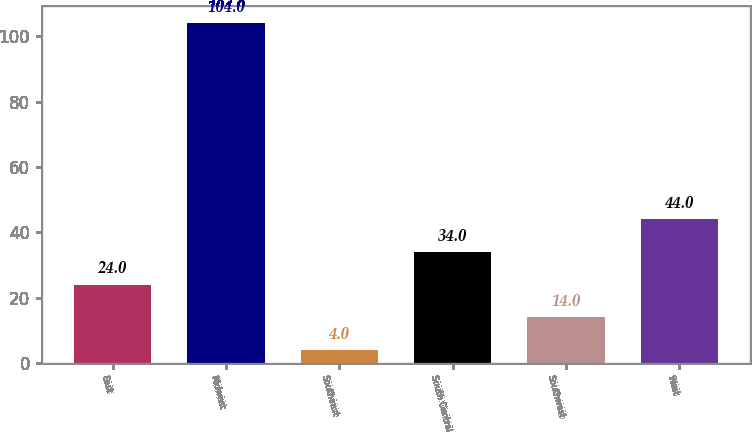Convert chart. <chart><loc_0><loc_0><loc_500><loc_500><bar_chart><fcel>East<fcel>Midwest<fcel>Southeast<fcel>South Central<fcel>Southwest<fcel>West<nl><fcel>24<fcel>104<fcel>4<fcel>34<fcel>14<fcel>44<nl></chart> 